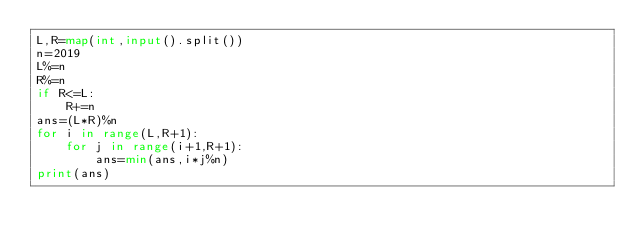Convert code to text. <code><loc_0><loc_0><loc_500><loc_500><_Python_>L,R=map(int,input().split())
n=2019
L%=n
R%=n
if R<=L:
    R+=n
ans=(L*R)%n
for i in range(L,R+1):
    for j in range(i+1,R+1):
        ans=min(ans,i*j%n)
print(ans)</code> 